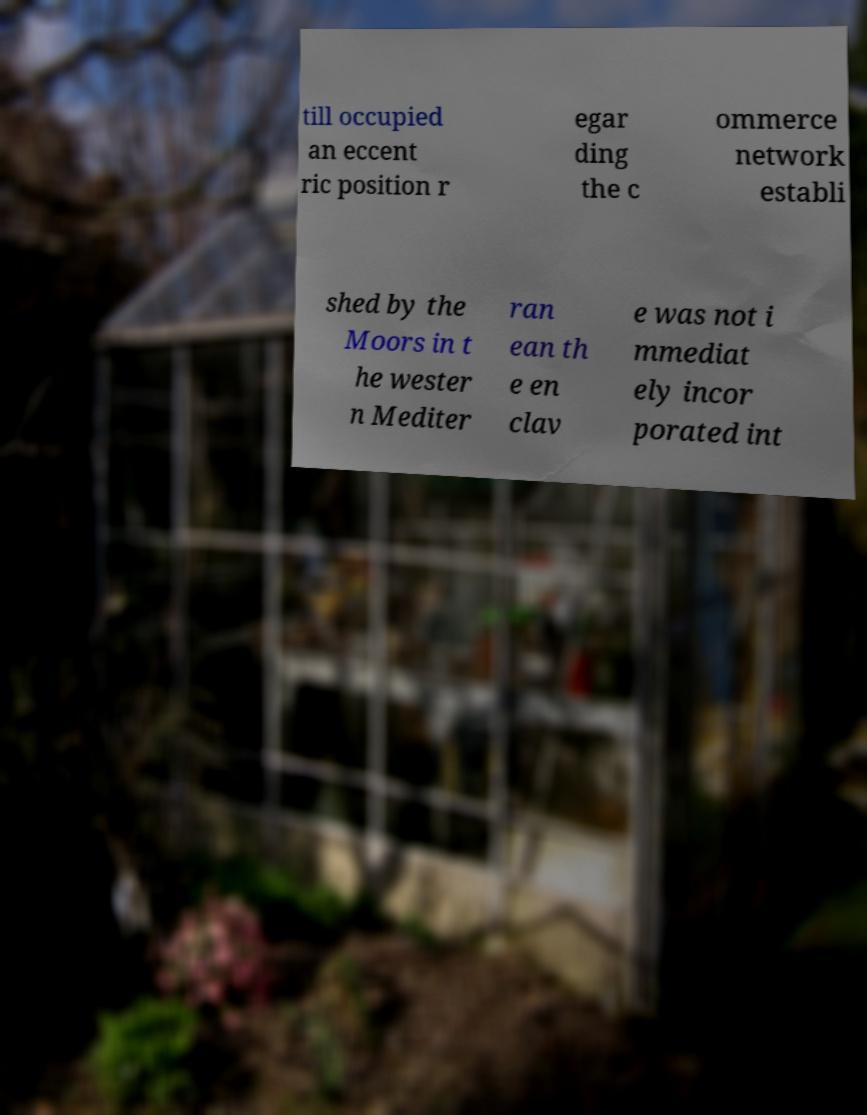There's text embedded in this image that I need extracted. Can you transcribe it verbatim? till occupied an eccent ric position r egar ding the c ommerce network establi shed by the Moors in t he wester n Mediter ran ean th e en clav e was not i mmediat ely incor porated int 